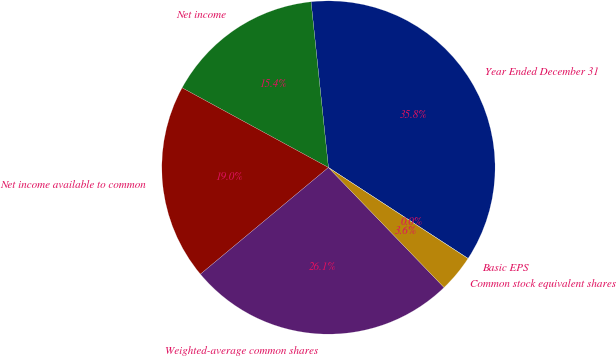<chart> <loc_0><loc_0><loc_500><loc_500><pie_chart><fcel>Year Ended December 31<fcel>Net income<fcel>Net income available to common<fcel>Weighted-average common shares<fcel>Common stock equivalent shares<fcel>Basic EPS<nl><fcel>35.85%<fcel>15.4%<fcel>18.99%<fcel>26.15%<fcel>3.6%<fcel>0.01%<nl></chart> 